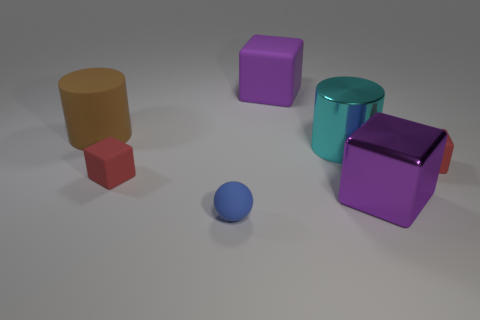Subtract all large rubber cubes. How many cubes are left? 3 Add 1 small red matte blocks. How many objects exist? 8 Subtract all red cubes. How many cubes are left? 2 Subtract all spheres. How many objects are left? 6 Subtract 4 blocks. How many blocks are left? 0 Add 7 large cyan metal things. How many large cyan metal things are left? 8 Add 2 small matte cubes. How many small matte cubes exist? 4 Subtract 0 green blocks. How many objects are left? 7 Subtract all red spheres. Subtract all brown blocks. How many spheres are left? 1 Subtract all green cubes. How many brown cylinders are left? 1 